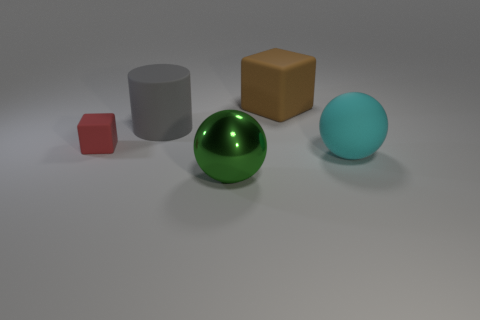The gray thing that is made of the same material as the red thing is what size?
Your response must be concise. Large. There is a object in front of the large matte object that is in front of the gray cylinder; what is its shape?
Offer a very short reply. Sphere. What size is the thing that is both behind the red rubber block and on the right side of the big green ball?
Your answer should be very brief. Large. Are there any big cyan matte things that have the same shape as the gray rubber object?
Your answer should be compact. No. Is there any other thing that is the same shape as the large metallic thing?
Make the answer very short. Yes. There is a block on the left side of the large sphere that is in front of the large ball that is to the right of the big green shiny object; what is its material?
Make the answer very short. Rubber. Is there a cylinder that has the same size as the red matte cube?
Your answer should be compact. No. The matte thing in front of the red object behind the big green metal thing is what color?
Your answer should be compact. Cyan. What number of big gray metal blocks are there?
Give a very brief answer. 0. Does the matte ball have the same color as the small rubber block?
Give a very brief answer. No. 